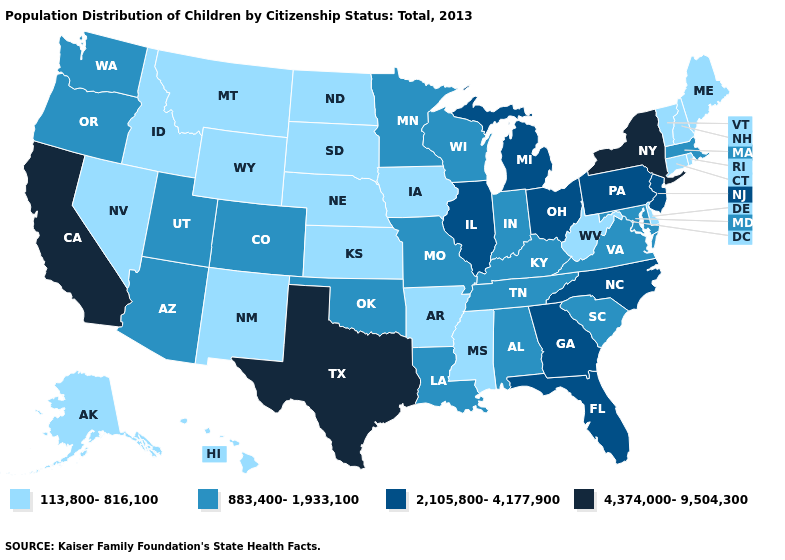Does California have the highest value in the West?
Write a very short answer. Yes. Does the map have missing data?
Be succinct. No. Name the states that have a value in the range 113,800-816,100?
Be succinct. Alaska, Arkansas, Connecticut, Delaware, Hawaii, Idaho, Iowa, Kansas, Maine, Mississippi, Montana, Nebraska, Nevada, New Hampshire, New Mexico, North Dakota, Rhode Island, South Dakota, Vermont, West Virginia, Wyoming. Which states hav the highest value in the MidWest?
Be succinct. Illinois, Michigan, Ohio. What is the highest value in the USA?
Write a very short answer. 4,374,000-9,504,300. Among the states that border Missouri , does Tennessee have the lowest value?
Short answer required. No. Does the map have missing data?
Write a very short answer. No. Name the states that have a value in the range 2,105,800-4,177,900?
Be succinct. Florida, Georgia, Illinois, Michigan, New Jersey, North Carolina, Ohio, Pennsylvania. Is the legend a continuous bar?
Quick response, please. No. Name the states that have a value in the range 2,105,800-4,177,900?
Keep it brief. Florida, Georgia, Illinois, Michigan, New Jersey, North Carolina, Ohio, Pennsylvania. Does the map have missing data?
Be succinct. No. What is the lowest value in the USA?
Quick response, please. 113,800-816,100. What is the highest value in the USA?
Answer briefly. 4,374,000-9,504,300. Name the states that have a value in the range 2,105,800-4,177,900?
Answer briefly. Florida, Georgia, Illinois, Michigan, New Jersey, North Carolina, Ohio, Pennsylvania. 